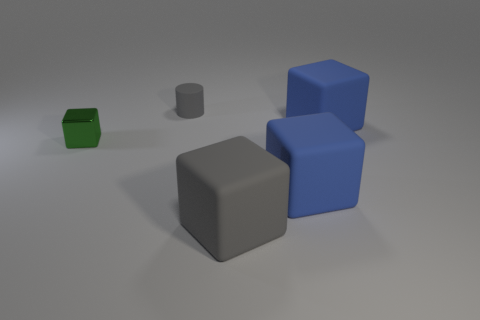There is a big matte object that is right of the blue matte cube in front of the green metallic block; how many rubber objects are behind it?
Provide a short and direct response. 1. Are there any other things that are the same color as the shiny cube?
Your response must be concise. No. What number of tiny things are both in front of the rubber cylinder and on the right side of the green cube?
Offer a terse response. 0. There is a blue object that is in front of the green object; is its size the same as the blue cube behind the green metal cube?
Keep it short and to the point. Yes. What number of objects are gray rubber cylinders that are on the right side of the small green thing or cylinders?
Make the answer very short. 1. What is the material of the blue cube behind the green shiny block?
Ensure brevity in your answer.  Rubber. What is the material of the small green cube?
Offer a very short reply. Metal. There is a blue thing right of the blue rubber block left of the block behind the tiny green metallic thing; what is its material?
Provide a succinct answer. Rubber. Are there any other things that have the same material as the small green thing?
Your answer should be compact. No. There is a shiny block; is its size the same as the gray thing that is on the right side of the tiny gray rubber object?
Offer a terse response. No. 